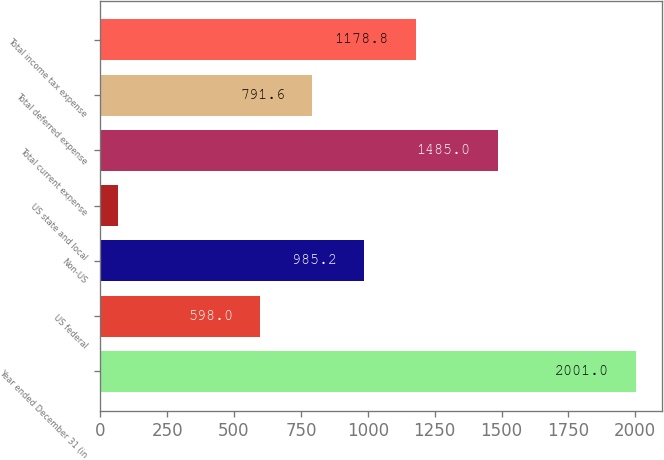<chart> <loc_0><loc_0><loc_500><loc_500><bar_chart><fcel>Year ended December 31 (in<fcel>US federal<fcel>Non-US<fcel>US state and local<fcel>Total current expense<fcel>Total deferred expense<fcel>Total income tax expense<nl><fcel>2001<fcel>598<fcel>985.2<fcel>65<fcel>1485<fcel>791.6<fcel>1178.8<nl></chart> 